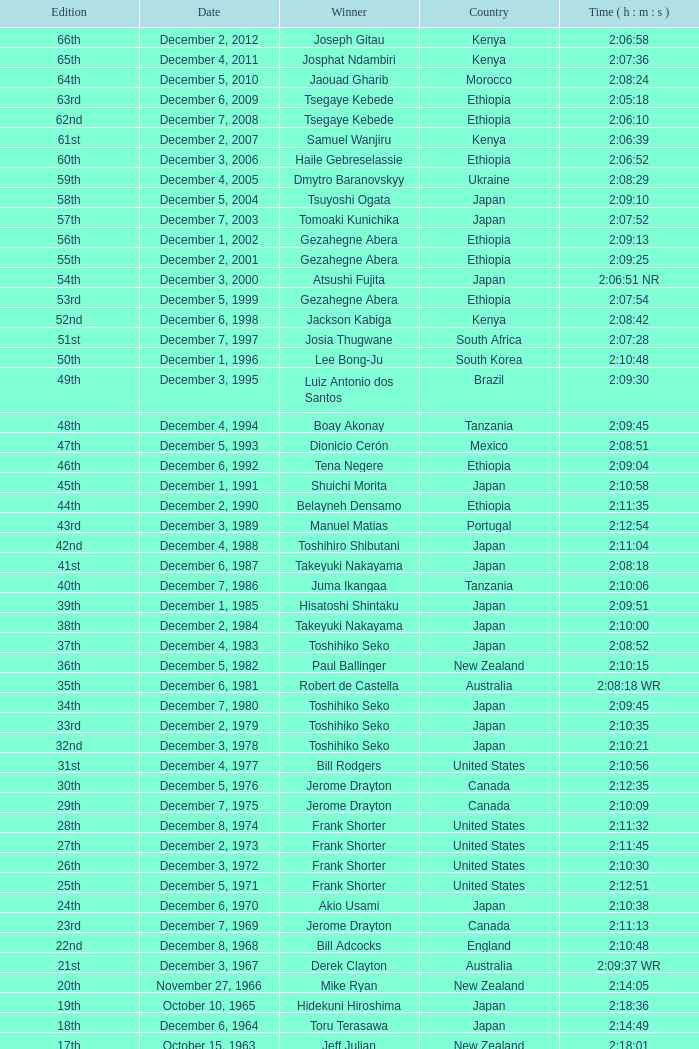Who claimed the title in the 23rd edition? Jerome Drayton. 